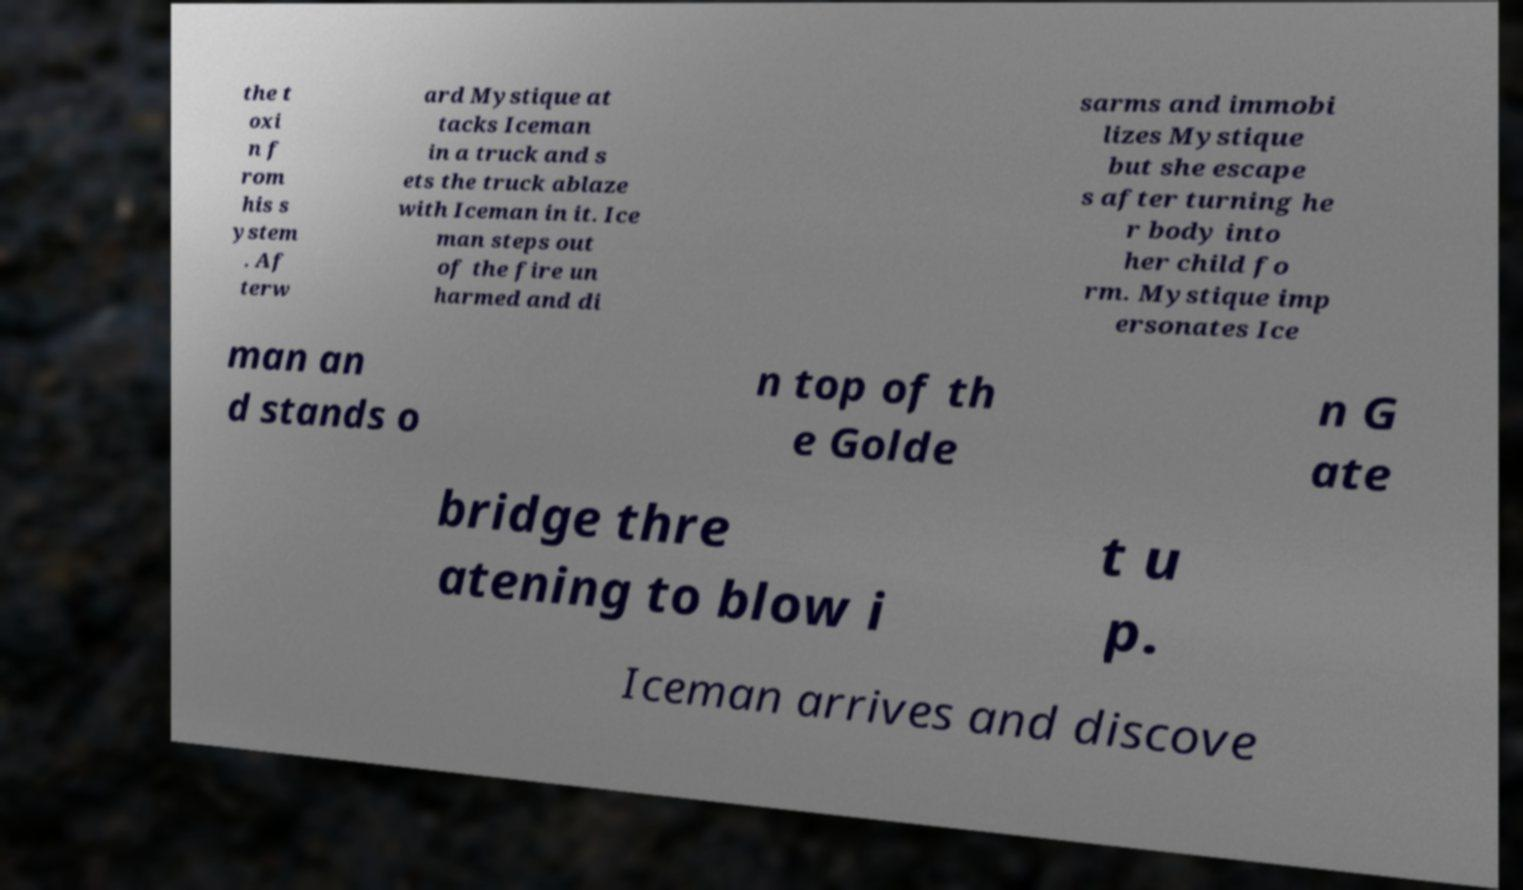There's text embedded in this image that I need extracted. Can you transcribe it verbatim? the t oxi n f rom his s ystem . Af terw ard Mystique at tacks Iceman in a truck and s ets the truck ablaze with Iceman in it. Ice man steps out of the fire un harmed and di sarms and immobi lizes Mystique but she escape s after turning he r body into her child fo rm. Mystique imp ersonates Ice man an d stands o n top of th e Golde n G ate bridge thre atening to blow i t u p. Iceman arrives and discove 